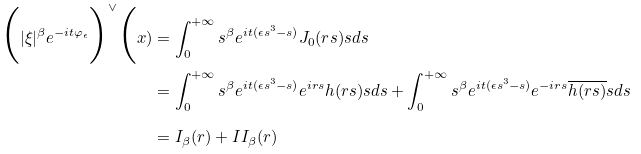<formula> <loc_0><loc_0><loc_500><loc_500>\Big ( | \xi | ^ { \beta } e ^ { - i t \varphi _ { \epsilon } } \Big ) ^ { \vee } \Big ( x ) & = \int _ { 0 } ^ { + \infty } s ^ { \beta } e ^ { i t ( \epsilon s ^ { 3 } - s ) } J _ { 0 } ( r s ) s d s \\ & = \int _ { 0 } ^ { + \infty } s ^ { \beta } e ^ { i t ( \epsilon s ^ { 3 } - s ) } e ^ { i r s } h ( r s ) s d s + \int _ { 0 } ^ { + \infty } s ^ { \beta } e ^ { i t ( \epsilon s ^ { 3 } - s ) } e ^ { - i r s } \overline { h ( r s ) } s d s \\ & = I _ { \beta } ( r ) + I I _ { \beta } ( r )</formula> 